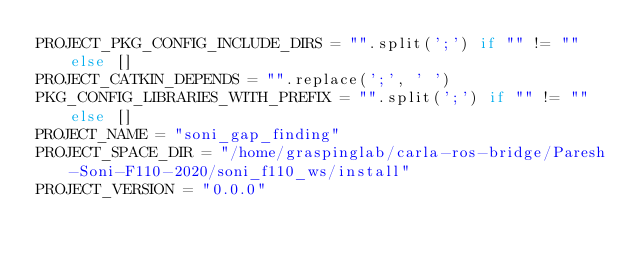Convert code to text. <code><loc_0><loc_0><loc_500><loc_500><_Python_>PROJECT_PKG_CONFIG_INCLUDE_DIRS = "".split(';') if "" != "" else []
PROJECT_CATKIN_DEPENDS = "".replace(';', ' ')
PKG_CONFIG_LIBRARIES_WITH_PREFIX = "".split(';') if "" != "" else []
PROJECT_NAME = "soni_gap_finding"
PROJECT_SPACE_DIR = "/home/graspinglab/carla-ros-bridge/Paresh-Soni-F110-2020/soni_f110_ws/install"
PROJECT_VERSION = "0.0.0"
</code> 